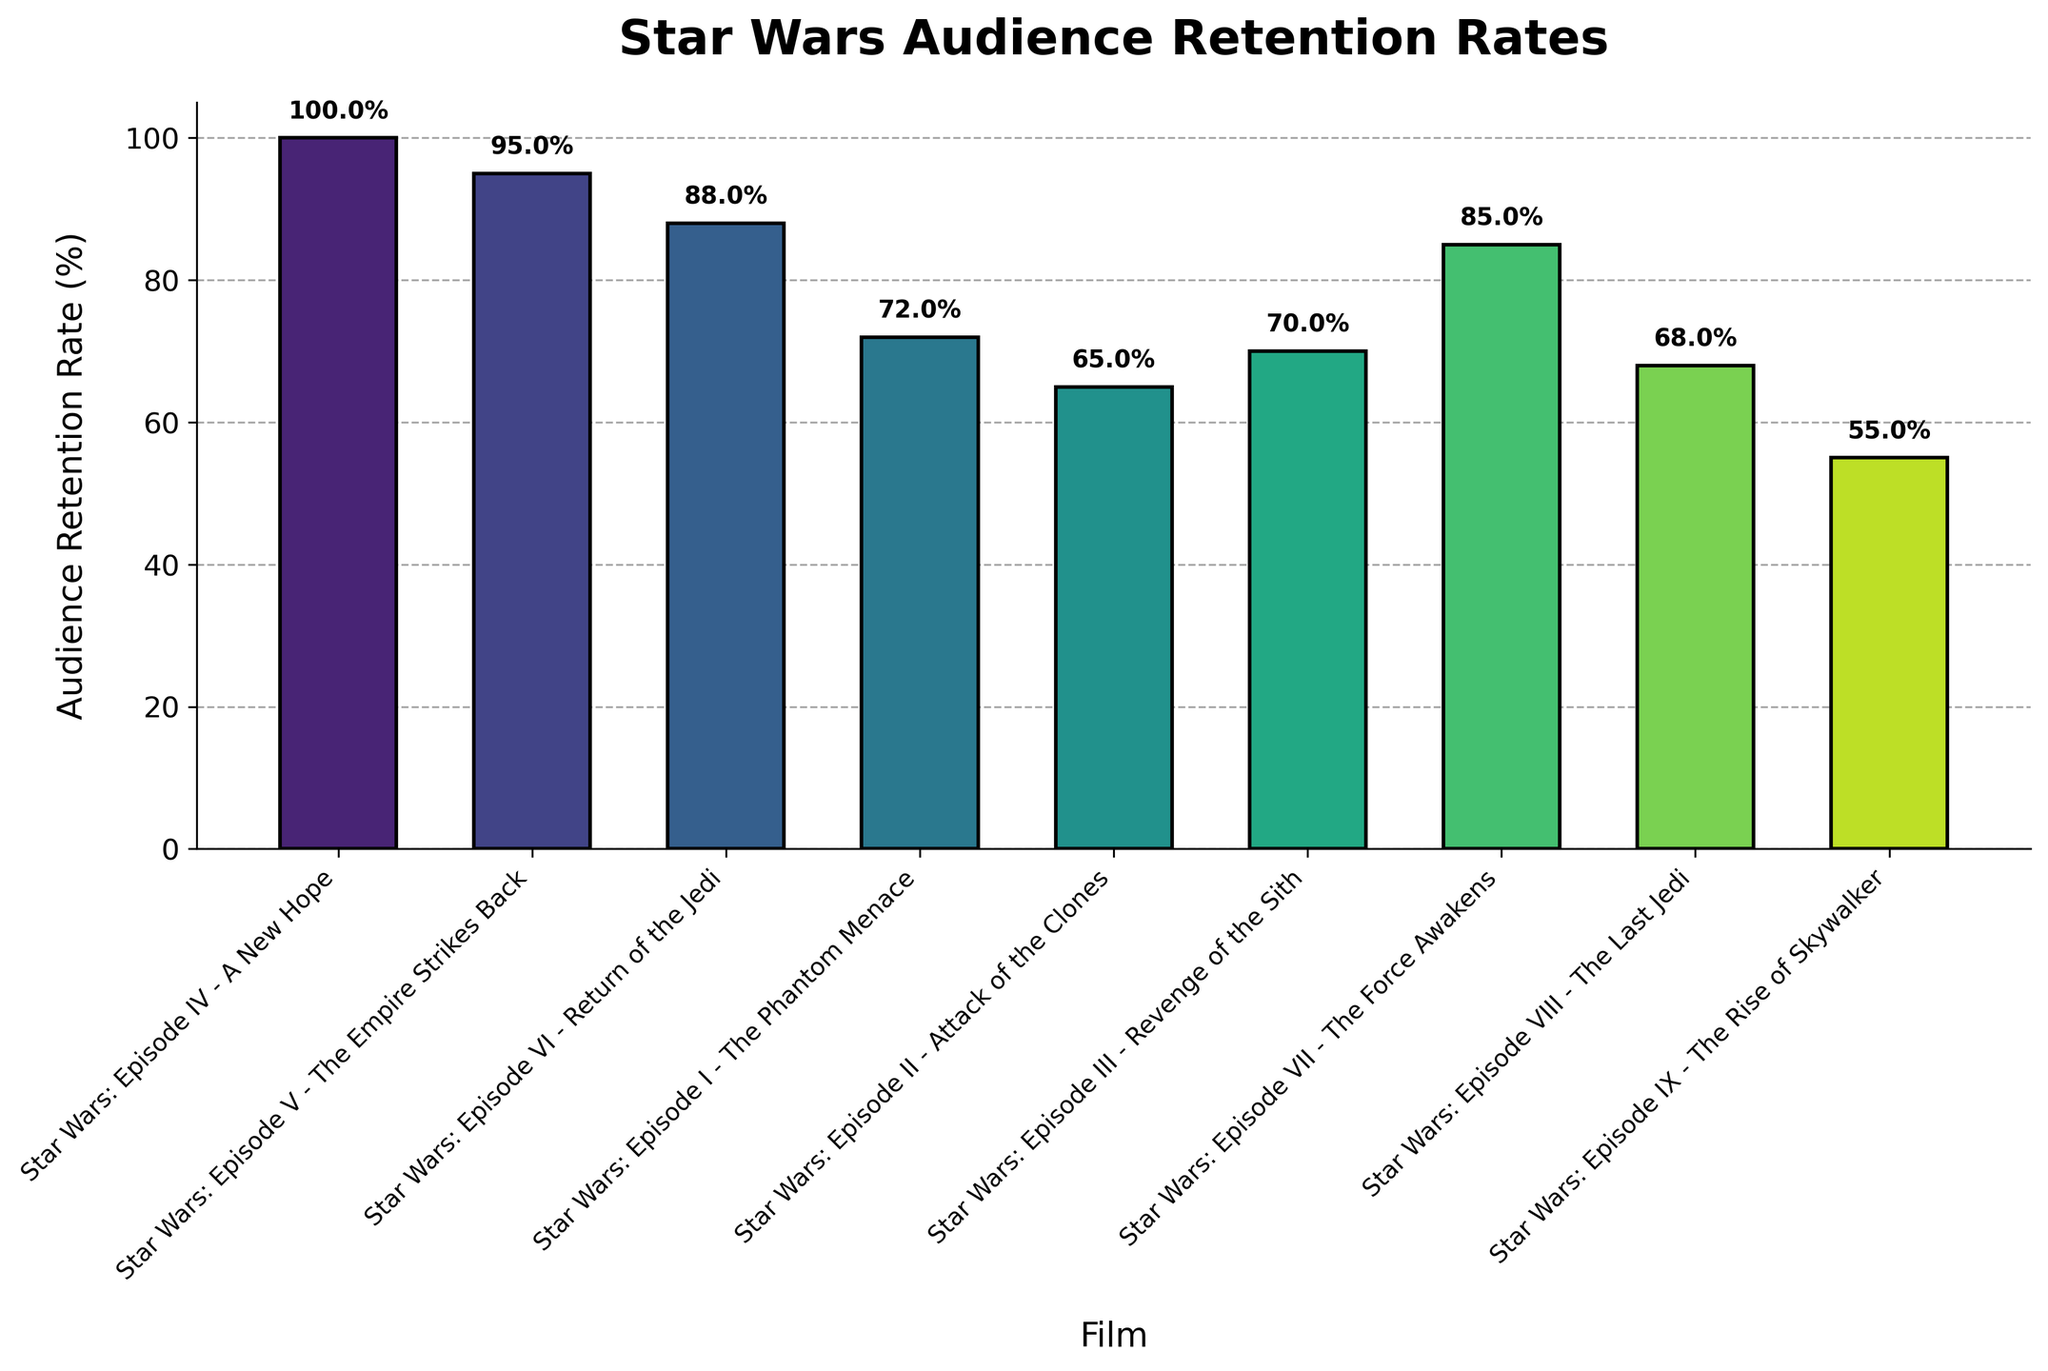What's the title of the chart? The title is the text prominently displayed on top of the chart. The title is "Star Wars Audience Retention Rates".
Answer: Star Wars Audience Retention Rates What is the lowest audience retention rate shown on the chart? The lowest retention rate can be found by identifying the smallest percentage figure on the chart. The lowest retention rate is 55% for "Star Wars: Episode IX - The Rise of Skywalker".
Answer: 55% Which film has the highest audience retention rate? Looking at the retention rates, the film with the highest rate is "Star Wars: Episode IV - A New Hope" with a retention rate of 100%.
Answer: Star Wars: Episode IV - A New Hope How does the audience retention rate of "Star Wars: Episode V - The Empire Strikes Back" compare to "Star Wars: Episode III - Revenge of the Sith"? "Star Wars: Episode V - The Empire Strikes Back" has a retention rate of 95%, while "Star Wars: Episode III - Revenge of the Sith" has a retention rate of 70%. 95% is higher than 70%.
Answer: Higher What is the average audience retention rate across all films in the series? Adding all the retention rates together and then dividing by the number of films gives the average. (100 + 95 + 88 + 72 + 65 + 70 + 85 + 68 + 55)/9 = 77.56% (rounded to two decimal places)
Answer: 77.56% Which episode has a retention rate closest to 70%? Scanning the retention rates for the closest value to 70%, "Star Wars: Episode III - Revenge of the Sith" has a retention rate of exactly 70%.
Answer: Star Wars: Episode III - Revenge of the Sith How many films have an audience retention rate below 70%? Count the number of films with retention rates lower than 70%. There are four films: "Star Wars: Episode II - Attack of the Clones" (65%), "Star Wars: Episode VIII - The Last Jedi" (68%), "Star Wars: Episode I - The Phantom Menace" (72%), and "Star Wars: Episode IX - The Rise of Skywalker" (55%).
Answer: 4 What's the difference in retention rates between "Star Wars: Episode I - The Phantom Menace" and "Star Wars: Episode IV - A New Hope"? Subtract the retention rate of "Star Wars: Episode I - The Phantom Menace" (72%) from "Star Wars: Episode IV - A New Hope" (100%). So, 100% - 72% = 28%.
Answer: 28% Do any two films have the same audience retention rate? Scanning through the retention rates, none of the films have the same rate. Each film has a unique retention rate value.
Answer: No 